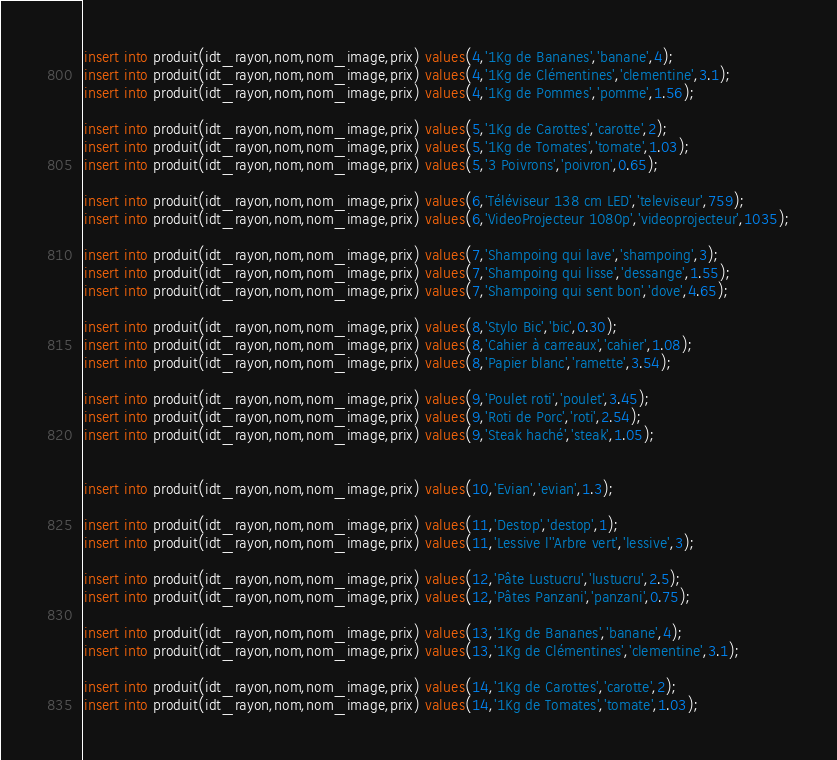<code> <loc_0><loc_0><loc_500><loc_500><_SQL_>insert into produit(idt_rayon,nom,nom_image,prix) values(4,'1Kg de Bananes','banane',4);
insert into produit(idt_rayon,nom,nom_image,prix) values(4,'1Kg de Clémentines','clementine',3.1);
insert into produit(idt_rayon,nom,nom_image,prix) values(4,'1Kg de Pommes','pomme',1.56);

insert into produit(idt_rayon,nom,nom_image,prix) values(5,'1Kg de Carottes','carotte',2);
insert into produit(idt_rayon,nom,nom_image,prix) values(5,'1Kg de Tomates','tomate',1.03);
insert into produit(idt_rayon,nom,nom_image,prix) values(5,'3 Poivrons','poivron',0.65);

insert into produit(idt_rayon,nom,nom_image,prix) values(6,'Téléviseur 138 cm LED','televiseur',759);
insert into produit(idt_rayon,nom,nom_image,prix) values(6,'VideoProjecteur 1080p','videoprojecteur',1035);

insert into produit(idt_rayon,nom,nom_image,prix) values(7,'Shampoing qui lave','shampoing',3);
insert into produit(idt_rayon,nom,nom_image,prix) values(7,'Shampoing qui lisse','dessange',1.55);
insert into produit(idt_rayon,nom,nom_image,prix) values(7,'Shampoing qui sent bon','dove',4.65);

insert into produit(idt_rayon,nom,nom_image,prix) values(8,'Stylo Bic','bic',0.30);
insert into produit(idt_rayon,nom,nom_image,prix) values(8,'Cahier à carreaux','cahier',1.08);
insert into produit(idt_rayon,nom,nom_image,prix) values(8,'Papier blanc','ramette',3.54);

insert into produit(idt_rayon,nom,nom_image,prix) values(9,'Poulet roti','poulet',3.45);
insert into produit(idt_rayon,nom,nom_image,prix) values(9,'Roti de Porc','roti',2.54);
insert into produit(idt_rayon,nom,nom_image,prix) values(9,'Steak haché','steak',1.05);


insert into produit(idt_rayon,nom,nom_image,prix) values(10,'Evian','evian',1.3);

insert into produit(idt_rayon,nom,nom_image,prix) values(11,'Destop','destop',1);
insert into produit(idt_rayon,nom,nom_image,prix) values(11,'Lessive l''Arbre vert','lessive',3);

insert into produit(idt_rayon,nom,nom_image,prix) values(12,'Pâte Lustucru','lustucru',2.5);
insert into produit(idt_rayon,nom,nom_image,prix) values(12,'Pâtes Panzani','panzani',0.75);

insert into produit(idt_rayon,nom,nom_image,prix) values(13,'1Kg de Bananes','banane',4);
insert into produit(idt_rayon,nom,nom_image,prix) values(13,'1Kg de Clémentines','clementine',3.1);

insert into produit(idt_rayon,nom,nom_image,prix) values(14,'1Kg de Carottes','carotte',2);
insert into produit(idt_rayon,nom,nom_image,prix) values(14,'1Kg de Tomates','tomate',1.03);
</code> 